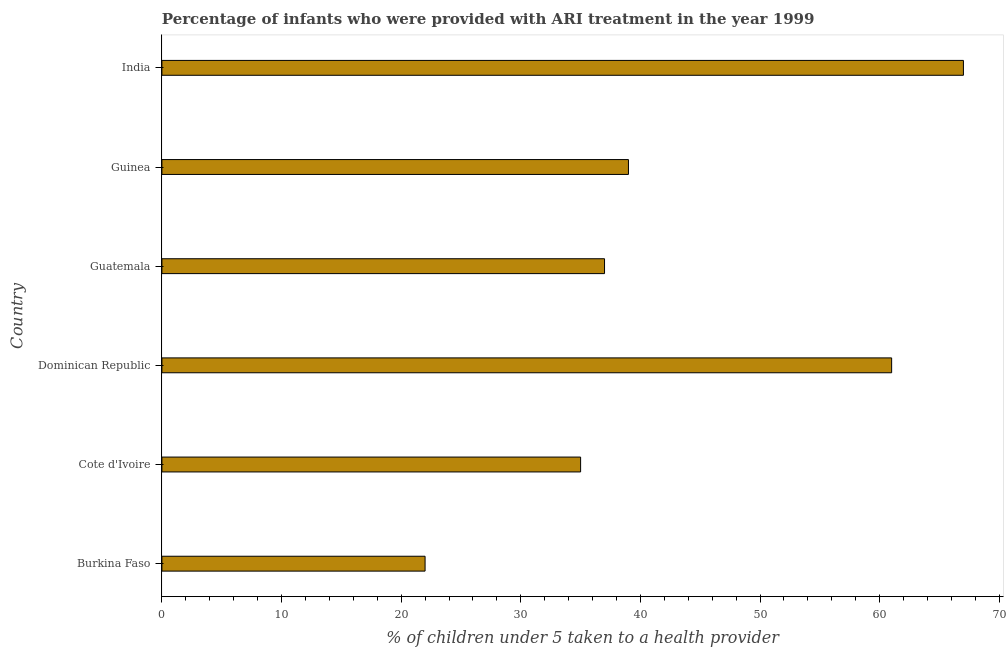Does the graph contain any zero values?
Offer a very short reply. No. What is the title of the graph?
Your answer should be compact. Percentage of infants who were provided with ARI treatment in the year 1999. What is the label or title of the X-axis?
Provide a succinct answer. % of children under 5 taken to a health provider. What is the label or title of the Y-axis?
Keep it short and to the point. Country. What is the percentage of children who were provided with ari treatment in Cote d'Ivoire?
Ensure brevity in your answer.  35. Across all countries, what is the maximum percentage of children who were provided with ari treatment?
Offer a terse response. 67. In which country was the percentage of children who were provided with ari treatment maximum?
Offer a very short reply. India. In which country was the percentage of children who were provided with ari treatment minimum?
Your answer should be very brief. Burkina Faso. What is the sum of the percentage of children who were provided with ari treatment?
Provide a succinct answer. 261. What is the difference between the percentage of children who were provided with ari treatment in Cote d'Ivoire and India?
Keep it short and to the point. -32. What is the average percentage of children who were provided with ari treatment per country?
Provide a short and direct response. 43.5. What is the median percentage of children who were provided with ari treatment?
Keep it short and to the point. 38. In how many countries, is the percentage of children who were provided with ari treatment greater than 30 %?
Your response must be concise. 5. What is the ratio of the percentage of children who were provided with ari treatment in Cote d'Ivoire to that in Guinea?
Ensure brevity in your answer.  0.9. Is the percentage of children who were provided with ari treatment in Guatemala less than that in India?
Offer a terse response. Yes. Is the difference between the percentage of children who were provided with ari treatment in Burkina Faso and Guinea greater than the difference between any two countries?
Your response must be concise. No. What is the difference between the highest and the second highest percentage of children who were provided with ari treatment?
Your response must be concise. 6. Is the sum of the percentage of children who were provided with ari treatment in Cote d'Ivoire and Guatemala greater than the maximum percentage of children who were provided with ari treatment across all countries?
Your answer should be very brief. Yes. In how many countries, is the percentage of children who were provided with ari treatment greater than the average percentage of children who were provided with ari treatment taken over all countries?
Provide a short and direct response. 2. Are all the bars in the graph horizontal?
Provide a succinct answer. Yes. How many countries are there in the graph?
Your answer should be compact. 6. Are the values on the major ticks of X-axis written in scientific E-notation?
Provide a succinct answer. No. What is the % of children under 5 taken to a health provider of Cote d'Ivoire?
Your answer should be compact. 35. What is the % of children under 5 taken to a health provider in Dominican Republic?
Offer a terse response. 61. What is the % of children under 5 taken to a health provider of India?
Your answer should be very brief. 67. What is the difference between the % of children under 5 taken to a health provider in Burkina Faso and Cote d'Ivoire?
Your response must be concise. -13. What is the difference between the % of children under 5 taken to a health provider in Burkina Faso and Dominican Republic?
Your response must be concise. -39. What is the difference between the % of children under 5 taken to a health provider in Burkina Faso and India?
Provide a short and direct response. -45. What is the difference between the % of children under 5 taken to a health provider in Cote d'Ivoire and Dominican Republic?
Your answer should be compact. -26. What is the difference between the % of children under 5 taken to a health provider in Cote d'Ivoire and Guatemala?
Offer a very short reply. -2. What is the difference between the % of children under 5 taken to a health provider in Cote d'Ivoire and India?
Offer a very short reply. -32. What is the difference between the % of children under 5 taken to a health provider in Dominican Republic and Guatemala?
Your answer should be very brief. 24. What is the difference between the % of children under 5 taken to a health provider in Dominican Republic and India?
Offer a terse response. -6. What is the difference between the % of children under 5 taken to a health provider in Guatemala and Guinea?
Ensure brevity in your answer.  -2. What is the difference between the % of children under 5 taken to a health provider in Guatemala and India?
Offer a terse response. -30. What is the ratio of the % of children under 5 taken to a health provider in Burkina Faso to that in Cote d'Ivoire?
Ensure brevity in your answer.  0.63. What is the ratio of the % of children under 5 taken to a health provider in Burkina Faso to that in Dominican Republic?
Make the answer very short. 0.36. What is the ratio of the % of children under 5 taken to a health provider in Burkina Faso to that in Guatemala?
Make the answer very short. 0.59. What is the ratio of the % of children under 5 taken to a health provider in Burkina Faso to that in Guinea?
Give a very brief answer. 0.56. What is the ratio of the % of children under 5 taken to a health provider in Burkina Faso to that in India?
Make the answer very short. 0.33. What is the ratio of the % of children under 5 taken to a health provider in Cote d'Ivoire to that in Dominican Republic?
Give a very brief answer. 0.57. What is the ratio of the % of children under 5 taken to a health provider in Cote d'Ivoire to that in Guatemala?
Offer a very short reply. 0.95. What is the ratio of the % of children under 5 taken to a health provider in Cote d'Ivoire to that in Guinea?
Provide a succinct answer. 0.9. What is the ratio of the % of children under 5 taken to a health provider in Cote d'Ivoire to that in India?
Your answer should be very brief. 0.52. What is the ratio of the % of children under 5 taken to a health provider in Dominican Republic to that in Guatemala?
Your response must be concise. 1.65. What is the ratio of the % of children under 5 taken to a health provider in Dominican Republic to that in Guinea?
Offer a terse response. 1.56. What is the ratio of the % of children under 5 taken to a health provider in Dominican Republic to that in India?
Ensure brevity in your answer.  0.91. What is the ratio of the % of children under 5 taken to a health provider in Guatemala to that in Guinea?
Make the answer very short. 0.95. What is the ratio of the % of children under 5 taken to a health provider in Guatemala to that in India?
Make the answer very short. 0.55. What is the ratio of the % of children under 5 taken to a health provider in Guinea to that in India?
Your response must be concise. 0.58. 